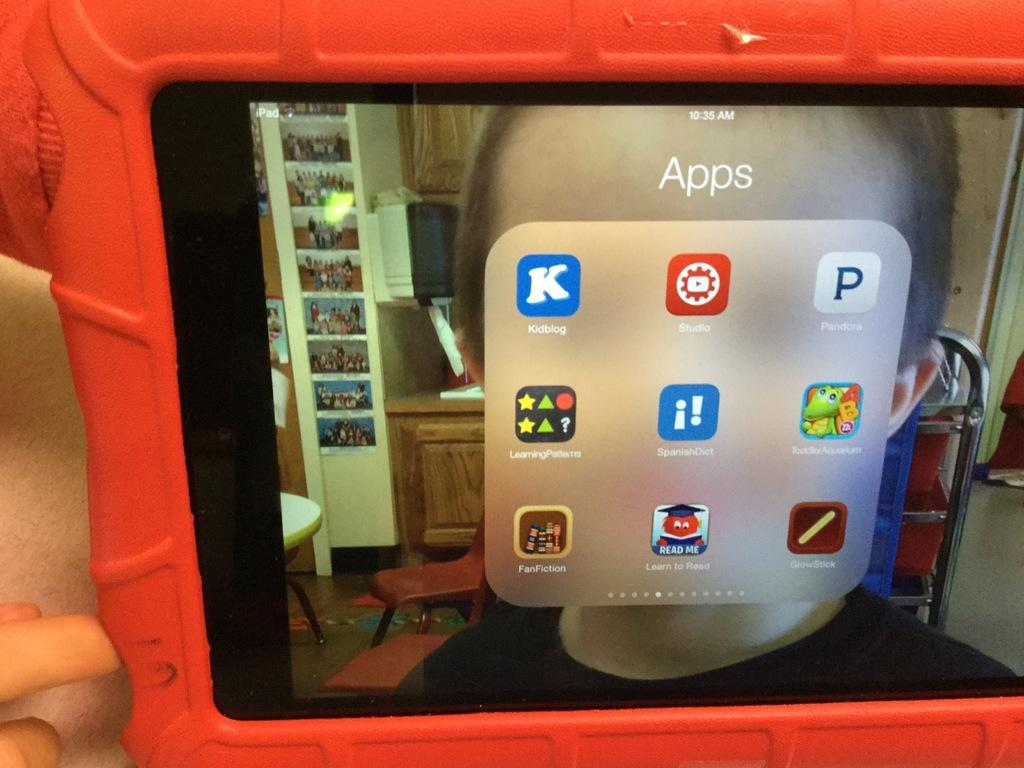<image>
Summarize the visual content of the image. tablet with red cover showing its apps icons at 10:35 am 